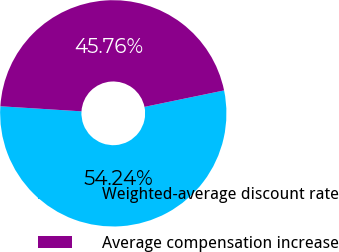Convert chart to OTSL. <chart><loc_0><loc_0><loc_500><loc_500><pie_chart><fcel>Weighted-average discount rate<fcel>Average compensation increase<nl><fcel>54.24%<fcel>45.76%<nl></chart> 